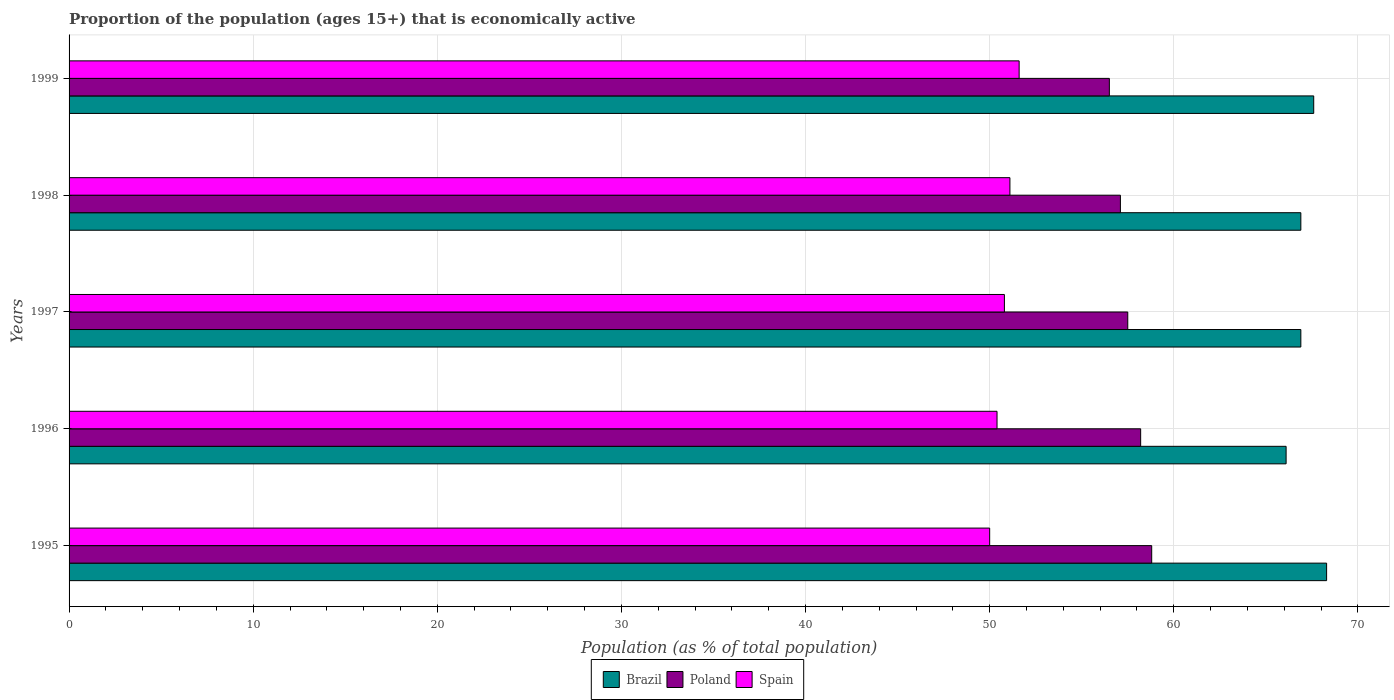How many different coloured bars are there?
Your response must be concise. 3. How many groups of bars are there?
Make the answer very short. 5. Are the number of bars on each tick of the Y-axis equal?
Your response must be concise. Yes. How many bars are there on the 3rd tick from the bottom?
Ensure brevity in your answer.  3. What is the label of the 1st group of bars from the top?
Your response must be concise. 1999. In how many cases, is the number of bars for a given year not equal to the number of legend labels?
Offer a very short reply. 0. What is the proportion of the population that is economically active in Spain in 1997?
Your response must be concise. 50.8. Across all years, what is the maximum proportion of the population that is economically active in Spain?
Ensure brevity in your answer.  51.6. Across all years, what is the minimum proportion of the population that is economically active in Spain?
Offer a terse response. 50. In which year was the proportion of the population that is economically active in Spain maximum?
Your answer should be very brief. 1999. In which year was the proportion of the population that is economically active in Brazil minimum?
Ensure brevity in your answer.  1996. What is the total proportion of the population that is economically active in Spain in the graph?
Your response must be concise. 253.9. What is the difference between the proportion of the population that is economically active in Spain in 1997 and that in 1999?
Keep it short and to the point. -0.8. What is the difference between the proportion of the population that is economically active in Brazil in 1995 and the proportion of the population that is economically active in Poland in 1999?
Provide a succinct answer. 11.8. What is the average proportion of the population that is economically active in Brazil per year?
Provide a short and direct response. 67.16. In the year 1999, what is the difference between the proportion of the population that is economically active in Brazil and proportion of the population that is economically active in Spain?
Your answer should be compact. 16. What is the ratio of the proportion of the population that is economically active in Spain in 1996 to that in 1999?
Ensure brevity in your answer.  0.98. What is the difference between the highest and the second highest proportion of the population that is economically active in Poland?
Keep it short and to the point. 0.6. What is the difference between the highest and the lowest proportion of the population that is economically active in Poland?
Ensure brevity in your answer.  2.3. What does the 3rd bar from the top in 1997 represents?
Your response must be concise. Brazil. Is it the case that in every year, the sum of the proportion of the population that is economically active in Brazil and proportion of the population that is economically active in Spain is greater than the proportion of the population that is economically active in Poland?
Provide a succinct answer. Yes. How many bars are there?
Offer a very short reply. 15. How many years are there in the graph?
Your answer should be very brief. 5. What is the difference between two consecutive major ticks on the X-axis?
Provide a short and direct response. 10. Does the graph contain any zero values?
Offer a terse response. No. How many legend labels are there?
Your answer should be very brief. 3. What is the title of the graph?
Give a very brief answer. Proportion of the population (ages 15+) that is economically active. Does "Romania" appear as one of the legend labels in the graph?
Ensure brevity in your answer.  No. What is the label or title of the X-axis?
Offer a terse response. Population (as % of total population). What is the label or title of the Y-axis?
Ensure brevity in your answer.  Years. What is the Population (as % of total population) in Brazil in 1995?
Ensure brevity in your answer.  68.3. What is the Population (as % of total population) in Poland in 1995?
Provide a succinct answer. 58.8. What is the Population (as % of total population) of Brazil in 1996?
Offer a terse response. 66.1. What is the Population (as % of total population) of Poland in 1996?
Make the answer very short. 58.2. What is the Population (as % of total population) in Spain in 1996?
Your answer should be compact. 50.4. What is the Population (as % of total population) in Brazil in 1997?
Keep it short and to the point. 66.9. What is the Population (as % of total population) in Poland in 1997?
Your response must be concise. 57.5. What is the Population (as % of total population) in Spain in 1997?
Give a very brief answer. 50.8. What is the Population (as % of total population) of Brazil in 1998?
Give a very brief answer. 66.9. What is the Population (as % of total population) in Poland in 1998?
Your response must be concise. 57.1. What is the Population (as % of total population) of Spain in 1998?
Ensure brevity in your answer.  51.1. What is the Population (as % of total population) of Brazil in 1999?
Keep it short and to the point. 67.6. What is the Population (as % of total population) of Poland in 1999?
Your answer should be very brief. 56.5. What is the Population (as % of total population) of Spain in 1999?
Offer a very short reply. 51.6. Across all years, what is the maximum Population (as % of total population) in Brazil?
Ensure brevity in your answer.  68.3. Across all years, what is the maximum Population (as % of total population) of Poland?
Ensure brevity in your answer.  58.8. Across all years, what is the maximum Population (as % of total population) in Spain?
Your answer should be very brief. 51.6. Across all years, what is the minimum Population (as % of total population) of Brazil?
Your answer should be compact. 66.1. Across all years, what is the minimum Population (as % of total population) of Poland?
Make the answer very short. 56.5. Across all years, what is the minimum Population (as % of total population) in Spain?
Provide a short and direct response. 50. What is the total Population (as % of total population) of Brazil in the graph?
Provide a short and direct response. 335.8. What is the total Population (as % of total population) in Poland in the graph?
Offer a very short reply. 288.1. What is the total Population (as % of total population) in Spain in the graph?
Offer a very short reply. 253.9. What is the difference between the Population (as % of total population) in Spain in 1995 and that in 1997?
Offer a terse response. -0.8. What is the difference between the Population (as % of total population) of Brazil in 1995 and that in 1998?
Your answer should be very brief. 1.4. What is the difference between the Population (as % of total population) in Poland in 1995 and that in 1998?
Your answer should be compact. 1.7. What is the difference between the Population (as % of total population) of Brazil in 1995 and that in 1999?
Your answer should be very brief. 0.7. What is the difference between the Population (as % of total population) in Spain in 1995 and that in 1999?
Offer a very short reply. -1.6. What is the difference between the Population (as % of total population) of Brazil in 1996 and that in 1997?
Your answer should be very brief. -0.8. What is the difference between the Population (as % of total population) in Brazil in 1996 and that in 1998?
Your answer should be compact. -0.8. What is the difference between the Population (as % of total population) in Spain in 1996 and that in 1998?
Your answer should be compact. -0.7. What is the difference between the Population (as % of total population) of Brazil in 1996 and that in 1999?
Give a very brief answer. -1.5. What is the difference between the Population (as % of total population) of Poland in 1996 and that in 1999?
Give a very brief answer. 1.7. What is the difference between the Population (as % of total population) of Spain in 1996 and that in 1999?
Your answer should be very brief. -1.2. What is the difference between the Population (as % of total population) in Brazil in 1997 and that in 1998?
Your answer should be compact. 0. What is the difference between the Population (as % of total population) of Poland in 1997 and that in 1998?
Keep it short and to the point. 0.4. What is the difference between the Population (as % of total population) in Spain in 1997 and that in 1998?
Your answer should be very brief. -0.3. What is the difference between the Population (as % of total population) in Poland in 1997 and that in 1999?
Offer a terse response. 1. What is the difference between the Population (as % of total population) in Brazil in 1998 and that in 1999?
Provide a short and direct response. -0.7. What is the difference between the Population (as % of total population) of Spain in 1998 and that in 1999?
Provide a succinct answer. -0.5. What is the difference between the Population (as % of total population) of Brazil in 1995 and the Population (as % of total population) of Poland in 1996?
Offer a very short reply. 10.1. What is the difference between the Population (as % of total population) in Brazil in 1995 and the Population (as % of total population) in Spain in 1997?
Offer a very short reply. 17.5. What is the difference between the Population (as % of total population) of Poland in 1995 and the Population (as % of total population) of Spain in 1999?
Ensure brevity in your answer.  7.2. What is the difference between the Population (as % of total population) of Brazil in 1996 and the Population (as % of total population) of Spain in 1997?
Offer a terse response. 15.3. What is the difference between the Population (as % of total population) in Poland in 1996 and the Population (as % of total population) in Spain in 1997?
Offer a very short reply. 7.4. What is the difference between the Population (as % of total population) in Brazil in 1996 and the Population (as % of total population) in Spain in 1999?
Your response must be concise. 14.5. What is the difference between the Population (as % of total population) of Poland in 1996 and the Population (as % of total population) of Spain in 1999?
Your answer should be compact. 6.6. What is the difference between the Population (as % of total population) in Brazil in 1997 and the Population (as % of total population) in Spain in 1998?
Your answer should be compact. 15.8. What is the difference between the Population (as % of total population) in Brazil in 1997 and the Population (as % of total population) in Spain in 1999?
Keep it short and to the point. 15.3. What is the difference between the Population (as % of total population) in Poland in 1997 and the Population (as % of total population) in Spain in 1999?
Offer a very short reply. 5.9. What is the difference between the Population (as % of total population) of Poland in 1998 and the Population (as % of total population) of Spain in 1999?
Give a very brief answer. 5.5. What is the average Population (as % of total population) in Brazil per year?
Make the answer very short. 67.16. What is the average Population (as % of total population) of Poland per year?
Provide a succinct answer. 57.62. What is the average Population (as % of total population) of Spain per year?
Keep it short and to the point. 50.78. In the year 1997, what is the difference between the Population (as % of total population) of Brazil and Population (as % of total population) of Poland?
Offer a very short reply. 9.4. In the year 1997, what is the difference between the Population (as % of total population) in Poland and Population (as % of total population) in Spain?
Provide a succinct answer. 6.7. In the year 1998, what is the difference between the Population (as % of total population) of Brazil and Population (as % of total population) of Spain?
Make the answer very short. 15.8. In the year 1998, what is the difference between the Population (as % of total population) of Poland and Population (as % of total population) of Spain?
Your response must be concise. 6. In the year 1999, what is the difference between the Population (as % of total population) of Brazil and Population (as % of total population) of Spain?
Make the answer very short. 16. In the year 1999, what is the difference between the Population (as % of total population) in Poland and Population (as % of total population) in Spain?
Keep it short and to the point. 4.9. What is the ratio of the Population (as % of total population) in Brazil in 1995 to that in 1996?
Provide a short and direct response. 1.03. What is the ratio of the Population (as % of total population) in Poland in 1995 to that in 1996?
Make the answer very short. 1.01. What is the ratio of the Population (as % of total population) of Spain in 1995 to that in 1996?
Your response must be concise. 0.99. What is the ratio of the Population (as % of total population) of Brazil in 1995 to that in 1997?
Provide a short and direct response. 1.02. What is the ratio of the Population (as % of total population) in Poland in 1995 to that in 1997?
Offer a terse response. 1.02. What is the ratio of the Population (as % of total population) of Spain in 1995 to that in 1997?
Offer a terse response. 0.98. What is the ratio of the Population (as % of total population) of Brazil in 1995 to that in 1998?
Make the answer very short. 1.02. What is the ratio of the Population (as % of total population) in Poland in 1995 to that in 1998?
Ensure brevity in your answer.  1.03. What is the ratio of the Population (as % of total population) in Spain in 1995 to that in 1998?
Give a very brief answer. 0.98. What is the ratio of the Population (as % of total population) in Brazil in 1995 to that in 1999?
Your answer should be very brief. 1.01. What is the ratio of the Population (as % of total population) in Poland in 1995 to that in 1999?
Keep it short and to the point. 1.04. What is the ratio of the Population (as % of total population) in Poland in 1996 to that in 1997?
Your answer should be very brief. 1.01. What is the ratio of the Population (as % of total population) of Spain in 1996 to that in 1997?
Your answer should be compact. 0.99. What is the ratio of the Population (as % of total population) of Brazil in 1996 to that in 1998?
Offer a very short reply. 0.99. What is the ratio of the Population (as % of total population) in Poland in 1996 to that in 1998?
Make the answer very short. 1.02. What is the ratio of the Population (as % of total population) in Spain in 1996 to that in 1998?
Your answer should be compact. 0.99. What is the ratio of the Population (as % of total population) in Brazil in 1996 to that in 1999?
Your answer should be compact. 0.98. What is the ratio of the Population (as % of total population) of Poland in 1996 to that in 1999?
Ensure brevity in your answer.  1.03. What is the ratio of the Population (as % of total population) in Spain in 1996 to that in 1999?
Your answer should be very brief. 0.98. What is the ratio of the Population (as % of total population) of Poland in 1997 to that in 1999?
Your response must be concise. 1.02. What is the ratio of the Population (as % of total population) of Spain in 1997 to that in 1999?
Your answer should be very brief. 0.98. What is the ratio of the Population (as % of total population) in Brazil in 1998 to that in 1999?
Provide a succinct answer. 0.99. What is the ratio of the Population (as % of total population) in Poland in 1998 to that in 1999?
Your answer should be compact. 1.01. What is the ratio of the Population (as % of total population) in Spain in 1998 to that in 1999?
Ensure brevity in your answer.  0.99. What is the difference between the highest and the second highest Population (as % of total population) in Spain?
Provide a short and direct response. 0.5. What is the difference between the highest and the lowest Population (as % of total population) in Brazil?
Provide a short and direct response. 2.2. What is the difference between the highest and the lowest Population (as % of total population) in Spain?
Offer a terse response. 1.6. 